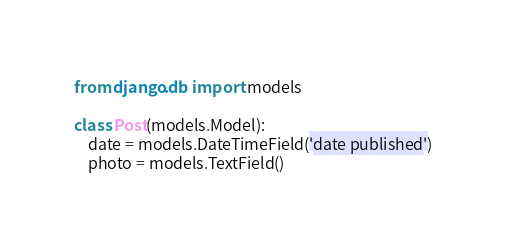Convert code to text. <code><loc_0><loc_0><loc_500><loc_500><_Python_>from django.db import models

class Post(models.Model):
    date = models.DateTimeField('date published')
    photo = models.TextField()
</code> 